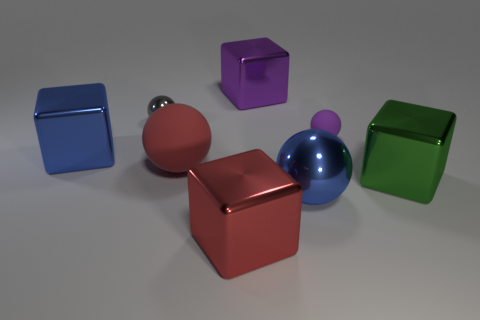Subtract all blue balls. How many balls are left? 3 Subtract all small purple spheres. How many spheres are left? 3 Subtract 2 spheres. How many spheres are left? 2 Subtract all yellow blocks. Subtract all red spheres. How many blocks are left? 4 Add 1 large red rubber things. How many objects exist? 9 Subtract all red rubber balls. Subtract all purple spheres. How many objects are left? 6 Add 5 large green blocks. How many large green blocks are left? 6 Add 1 big purple metal cubes. How many big purple metal cubes exist? 2 Subtract 0 purple cylinders. How many objects are left? 8 